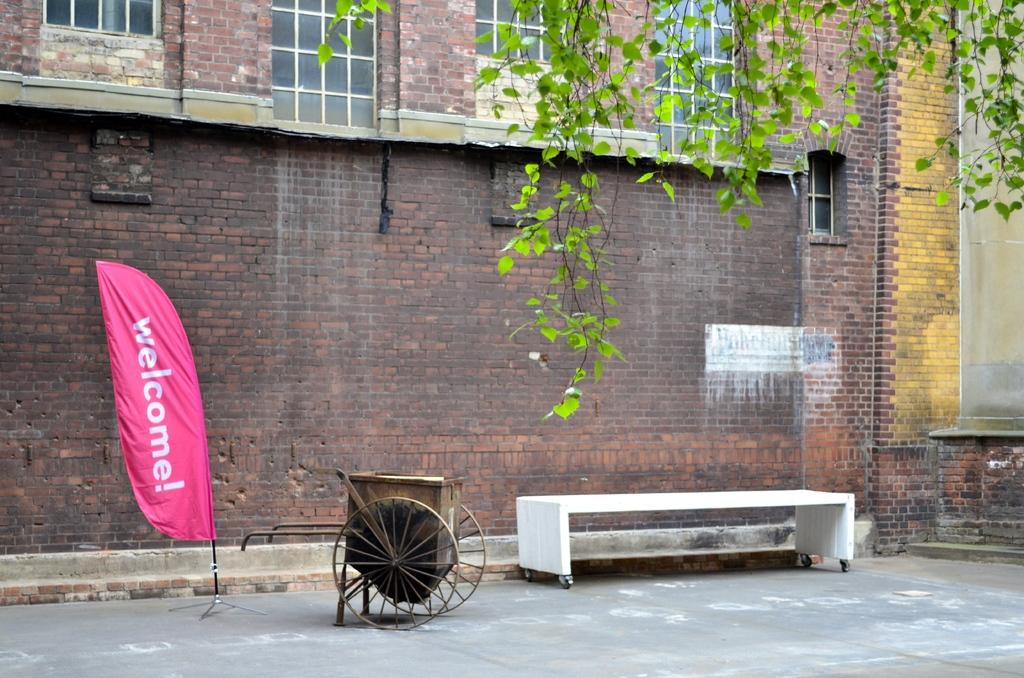What type of structure can be seen in the image? There is a building in the image. What is attached to the building? There is a hoarding in the image. What can be seen flying near the building? There is a flag in the image. What type of seating is present in the image? There is a bench in the image. What type of plant life is visible in the image? There is a tree in the image. Where is the throne located in the image? There is no throne present in the image. What type of care is being provided to the deer in the image? There are no deer present in the image. 